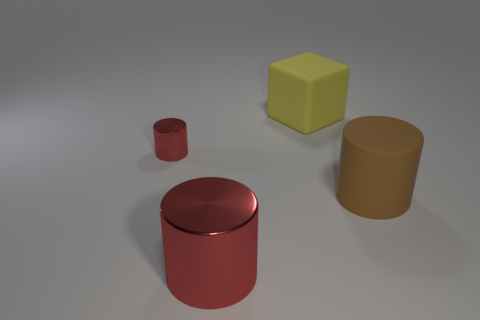Add 2 tiny red shiny cylinders. How many objects exist? 6 Subtract all cylinders. How many objects are left? 1 Add 2 large red things. How many large red things are left? 3 Add 3 large cyan metal spheres. How many large cyan metal spheres exist? 3 Subtract 1 yellow cubes. How many objects are left? 3 Subtract all yellow rubber things. Subtract all big yellow objects. How many objects are left? 2 